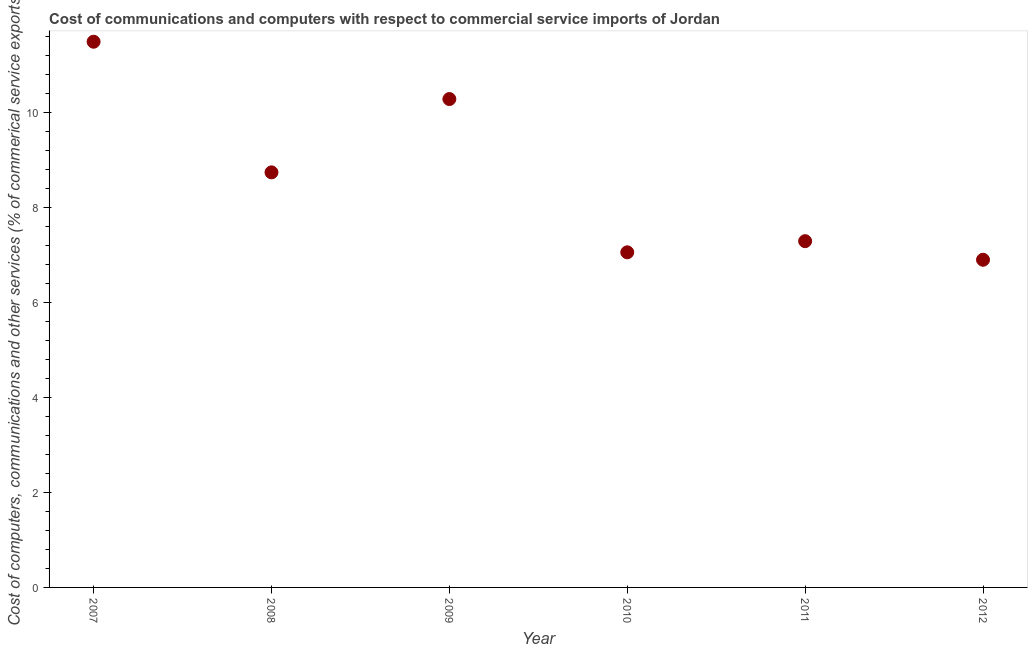What is the  computer and other services in 2007?
Ensure brevity in your answer.  11.49. Across all years, what is the maximum  computer and other services?
Provide a succinct answer. 11.49. Across all years, what is the minimum  computer and other services?
Your answer should be very brief. 6.9. In which year was the  computer and other services maximum?
Make the answer very short. 2007. In which year was the cost of communications minimum?
Your answer should be compact. 2012. What is the sum of the cost of communications?
Offer a very short reply. 51.78. What is the difference between the cost of communications in 2008 and 2012?
Your response must be concise. 1.84. What is the average  computer and other services per year?
Ensure brevity in your answer.  8.63. What is the median cost of communications?
Your answer should be compact. 8.02. In how many years, is the  computer and other services greater than 2.4 %?
Your response must be concise. 6. What is the ratio of the cost of communications in 2010 to that in 2012?
Ensure brevity in your answer.  1.02. What is the difference between the highest and the second highest  computer and other services?
Your response must be concise. 1.21. What is the difference between the highest and the lowest cost of communications?
Offer a very short reply. 4.59. In how many years, is the  computer and other services greater than the average  computer and other services taken over all years?
Provide a short and direct response. 3. Does the cost of communications monotonically increase over the years?
Offer a terse response. No. How many years are there in the graph?
Ensure brevity in your answer.  6. What is the difference between two consecutive major ticks on the Y-axis?
Give a very brief answer. 2. Does the graph contain any zero values?
Your answer should be very brief. No. What is the title of the graph?
Your answer should be compact. Cost of communications and computers with respect to commercial service imports of Jordan. What is the label or title of the X-axis?
Your answer should be very brief. Year. What is the label or title of the Y-axis?
Make the answer very short. Cost of computers, communications and other services (% of commerical service exports). What is the Cost of computers, communications and other services (% of commerical service exports) in 2007?
Provide a short and direct response. 11.49. What is the Cost of computers, communications and other services (% of commerical service exports) in 2008?
Keep it short and to the point. 8.74. What is the Cost of computers, communications and other services (% of commerical service exports) in 2009?
Your answer should be compact. 10.29. What is the Cost of computers, communications and other services (% of commerical service exports) in 2010?
Your answer should be compact. 7.06. What is the Cost of computers, communications and other services (% of commerical service exports) in 2011?
Your answer should be compact. 7.29. What is the Cost of computers, communications and other services (% of commerical service exports) in 2012?
Make the answer very short. 6.9. What is the difference between the Cost of computers, communications and other services (% of commerical service exports) in 2007 and 2008?
Provide a short and direct response. 2.75. What is the difference between the Cost of computers, communications and other services (% of commerical service exports) in 2007 and 2009?
Your response must be concise. 1.21. What is the difference between the Cost of computers, communications and other services (% of commerical service exports) in 2007 and 2010?
Offer a very short reply. 4.44. What is the difference between the Cost of computers, communications and other services (% of commerical service exports) in 2007 and 2011?
Offer a very short reply. 4.2. What is the difference between the Cost of computers, communications and other services (% of commerical service exports) in 2007 and 2012?
Offer a very short reply. 4.59. What is the difference between the Cost of computers, communications and other services (% of commerical service exports) in 2008 and 2009?
Provide a succinct answer. -1.54. What is the difference between the Cost of computers, communications and other services (% of commerical service exports) in 2008 and 2010?
Your answer should be compact. 1.68. What is the difference between the Cost of computers, communications and other services (% of commerical service exports) in 2008 and 2011?
Your answer should be very brief. 1.45. What is the difference between the Cost of computers, communications and other services (% of commerical service exports) in 2008 and 2012?
Provide a short and direct response. 1.84. What is the difference between the Cost of computers, communications and other services (% of commerical service exports) in 2009 and 2010?
Provide a short and direct response. 3.23. What is the difference between the Cost of computers, communications and other services (% of commerical service exports) in 2009 and 2011?
Ensure brevity in your answer.  2.99. What is the difference between the Cost of computers, communications and other services (% of commerical service exports) in 2009 and 2012?
Offer a terse response. 3.38. What is the difference between the Cost of computers, communications and other services (% of commerical service exports) in 2010 and 2011?
Give a very brief answer. -0.23. What is the difference between the Cost of computers, communications and other services (% of commerical service exports) in 2010 and 2012?
Give a very brief answer. 0.16. What is the difference between the Cost of computers, communications and other services (% of commerical service exports) in 2011 and 2012?
Give a very brief answer. 0.39. What is the ratio of the Cost of computers, communications and other services (% of commerical service exports) in 2007 to that in 2008?
Make the answer very short. 1.31. What is the ratio of the Cost of computers, communications and other services (% of commerical service exports) in 2007 to that in 2009?
Your response must be concise. 1.12. What is the ratio of the Cost of computers, communications and other services (% of commerical service exports) in 2007 to that in 2010?
Give a very brief answer. 1.63. What is the ratio of the Cost of computers, communications and other services (% of commerical service exports) in 2007 to that in 2011?
Provide a succinct answer. 1.58. What is the ratio of the Cost of computers, communications and other services (% of commerical service exports) in 2007 to that in 2012?
Your answer should be very brief. 1.67. What is the ratio of the Cost of computers, communications and other services (% of commerical service exports) in 2008 to that in 2009?
Ensure brevity in your answer.  0.85. What is the ratio of the Cost of computers, communications and other services (% of commerical service exports) in 2008 to that in 2010?
Offer a very short reply. 1.24. What is the ratio of the Cost of computers, communications and other services (% of commerical service exports) in 2008 to that in 2011?
Ensure brevity in your answer.  1.2. What is the ratio of the Cost of computers, communications and other services (% of commerical service exports) in 2008 to that in 2012?
Provide a succinct answer. 1.27. What is the ratio of the Cost of computers, communications and other services (% of commerical service exports) in 2009 to that in 2010?
Make the answer very short. 1.46. What is the ratio of the Cost of computers, communications and other services (% of commerical service exports) in 2009 to that in 2011?
Offer a very short reply. 1.41. What is the ratio of the Cost of computers, communications and other services (% of commerical service exports) in 2009 to that in 2012?
Your answer should be compact. 1.49. What is the ratio of the Cost of computers, communications and other services (% of commerical service exports) in 2011 to that in 2012?
Make the answer very short. 1.06. 